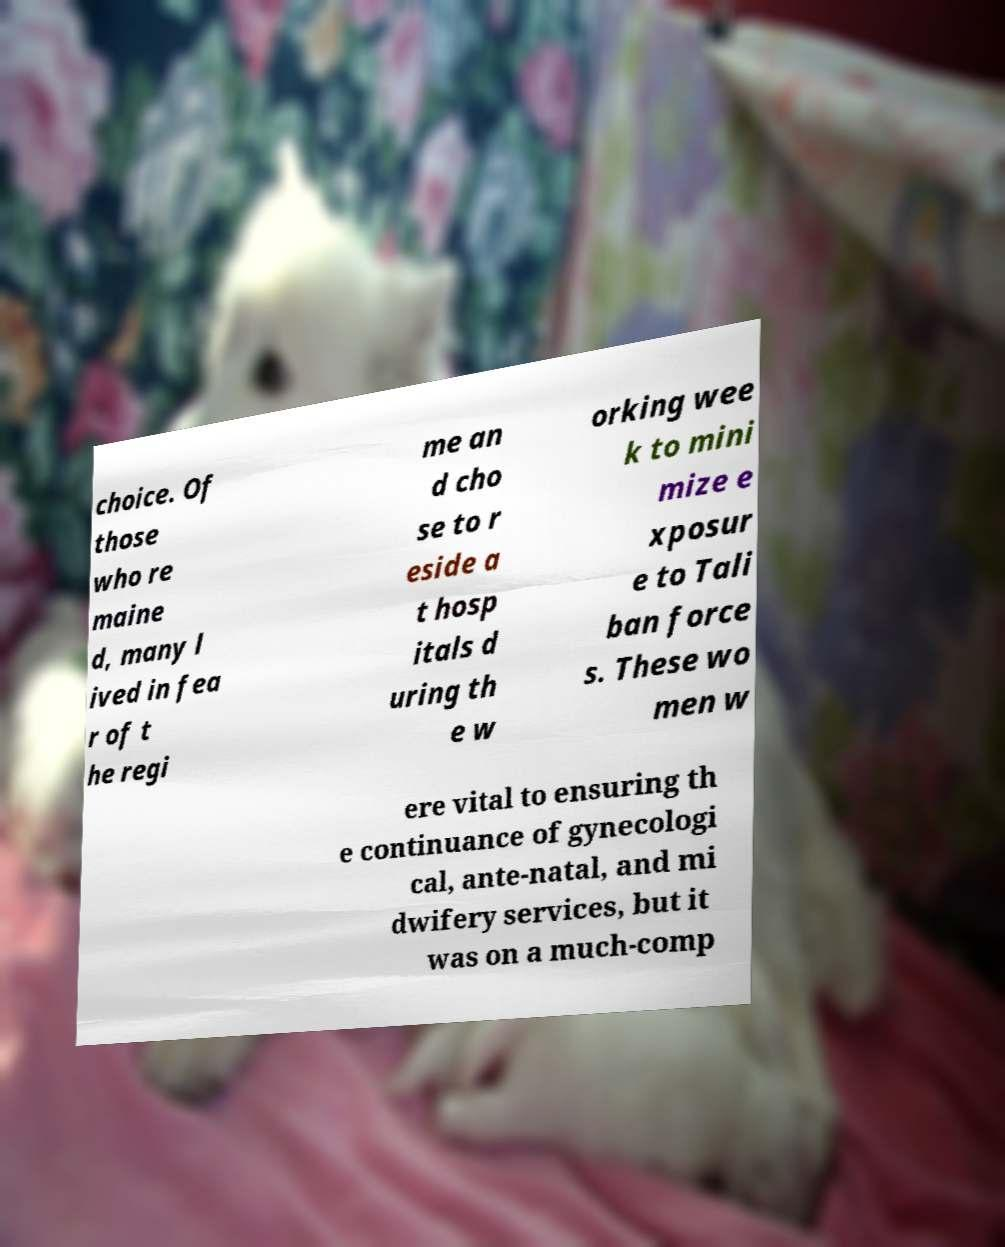I need the written content from this picture converted into text. Can you do that? choice. Of those who re maine d, many l ived in fea r of t he regi me an d cho se to r eside a t hosp itals d uring th e w orking wee k to mini mize e xposur e to Tali ban force s. These wo men w ere vital to ensuring th e continuance of gynecologi cal, ante-natal, and mi dwifery services, but it was on a much-comp 